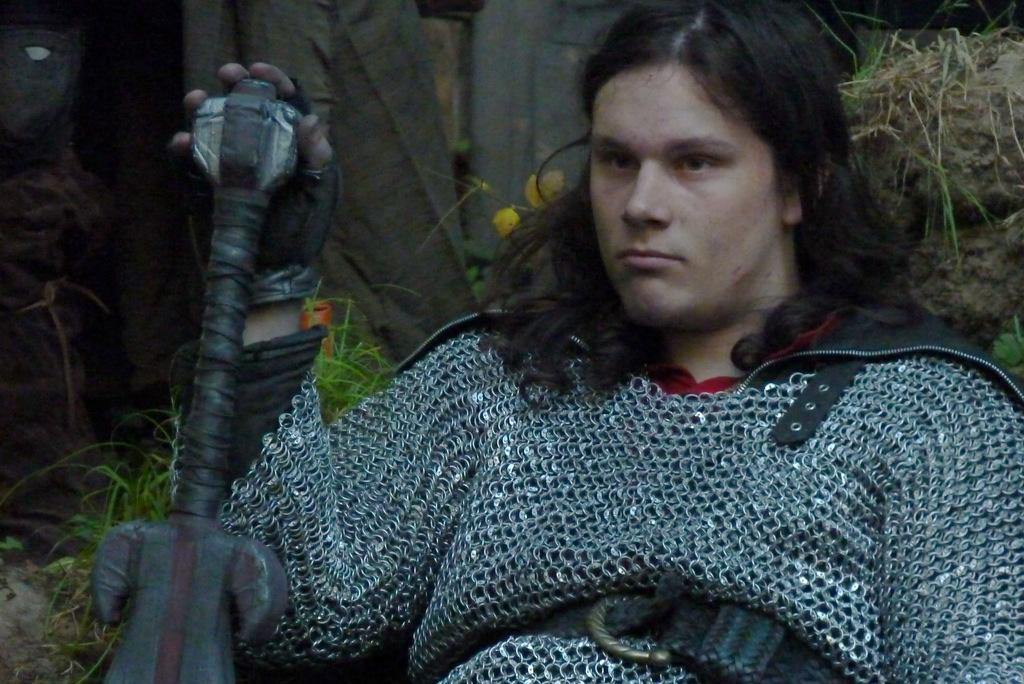Who or what is present in the image? There is a person in the image. What is the person wearing? The person is wearing a dress. What object is the person holding? The person is holding a stick. What else can be seen in the image besides the person? There are plants in the image. What type of quartz can be seen in the person's hand in the image? There is no quartz present in the image; the person is holding a stick. What scent is associated with the person in the image? There is no information about the person's scent in the image. 